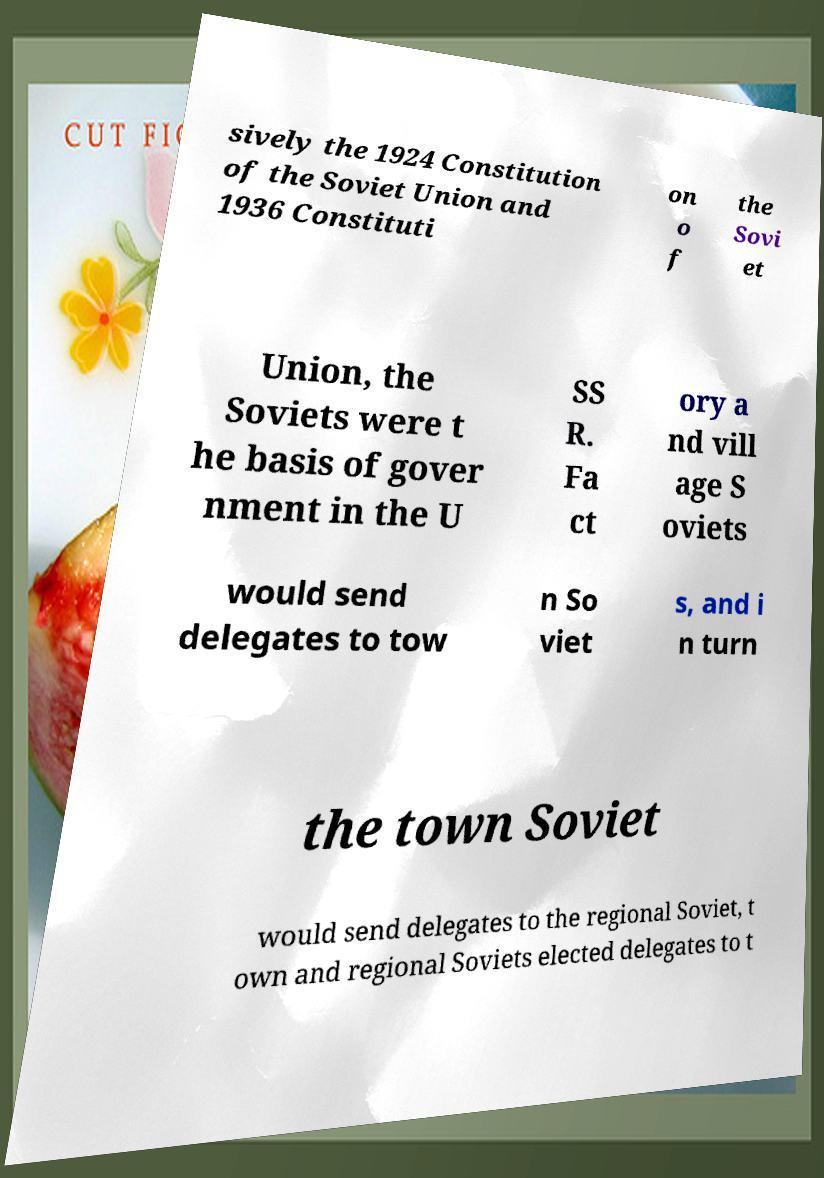For documentation purposes, I need the text within this image transcribed. Could you provide that? sively the 1924 Constitution of the Soviet Union and 1936 Constituti on o f the Sovi et Union, the Soviets were t he basis of gover nment in the U SS R. Fa ct ory a nd vill age S oviets would send delegates to tow n So viet s, and i n turn the town Soviet would send delegates to the regional Soviet, t own and regional Soviets elected delegates to t 